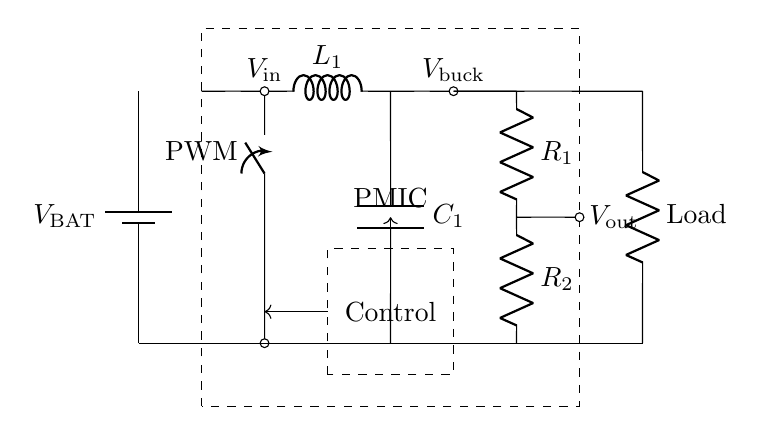What is the main purpose of the PMIC in this circuit? The PMIC, or Power Management Integrated Circuit, is responsible for managing the power distribution and regulation within the mobile device. It ensures efficient battery usage by controlling voltage levels and current distributions to various components.
Answer: managing power What type of converter is utilized in this circuit? The circuit uses a buck converter, which steps down the voltage from the battery to a lower voltage suitable for the load while maintaining high efficiency. This is indicated by the inductor labeled L1 and the configuration around it.
Answer: buck converter What component is used for energy storage in this circuit? The component used for energy storage is the capacitor labeled C1, which stores charge and helps regulate the voltage output of the buck converter. The placement of C1 in parallel with the output indicates it plays a crucial role in energy stabilization.
Answer: capacitor What are R1 and R2 used for in this circuit? R1 and R2 are utilized as resistive voltage dividers to extract a lower voltage from the higher voltage levels in the circuit, commonly used for powering specific components or for sensing purposes. Their connection in series indicates they divide voltage between them.
Answer: voltage dividers What is the purpose of the control block in the PMIC? The control block in the PMIC is designed to regulate and manage various functions such as switching the buck converter on and off, adjusting output voltage, and ensuring overall efficiency. Signals directed into and out of this block indicate its role in system management.
Answer: regulation What can be inferred about the 'Load' in this circuit? The 'Load' represents the device or circuit component that utilizes the power supplied by the PMIC; it is located at the output of the PMIC and indicates where the regulated voltage will be delivered. The presence of the load suggests the end usage of the power being managed.
Answer: device component 